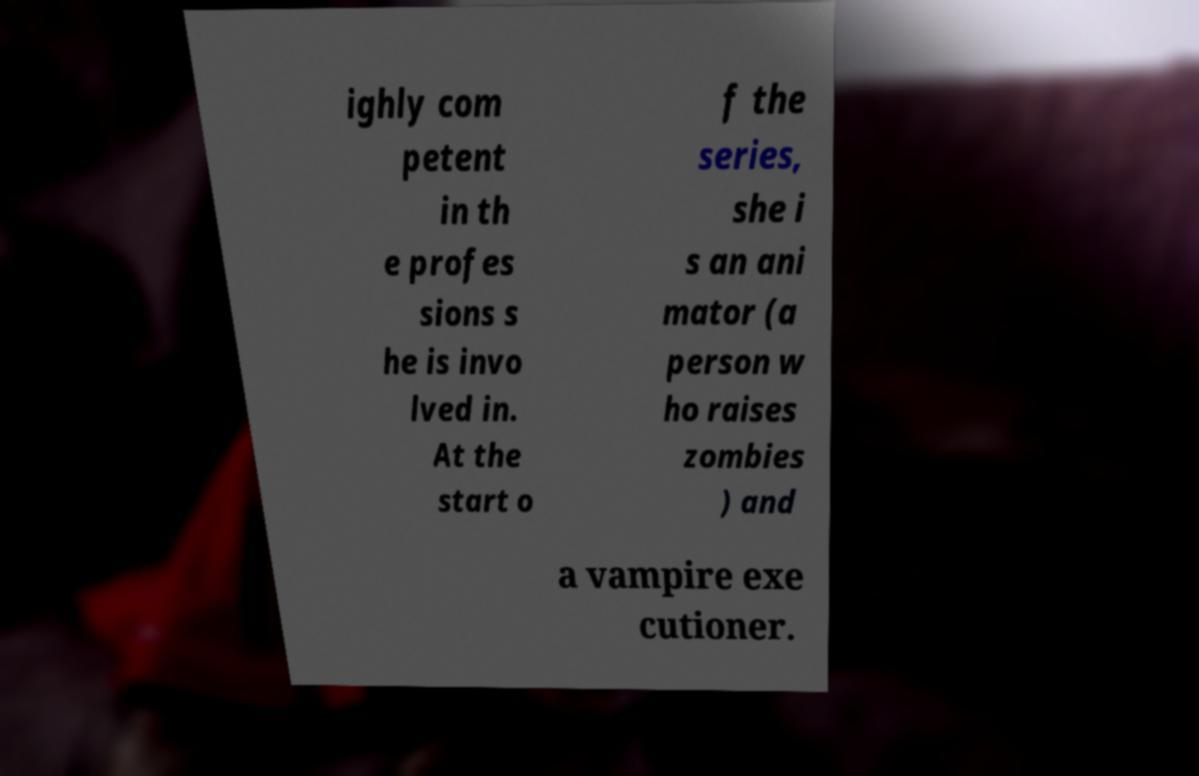Can you read and provide the text displayed in the image?This photo seems to have some interesting text. Can you extract and type it out for me? ighly com petent in th e profes sions s he is invo lved in. At the start o f the series, she i s an ani mator (a person w ho raises zombies ) and a vampire exe cutioner. 